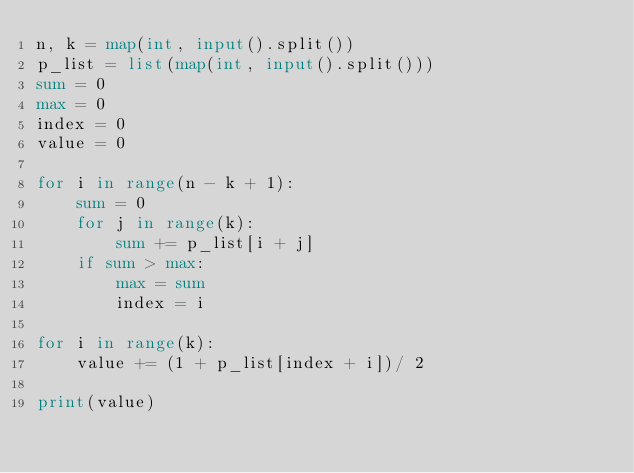Convert code to text. <code><loc_0><loc_0><loc_500><loc_500><_Python_>n, k = map(int, input().split())
p_list = list(map(int, input().split()))
sum = 0
max = 0
index = 0
value = 0

for i in range(n - k + 1):
    sum = 0
    for j in range(k):
        sum += p_list[i + j]
    if sum > max:
        max = sum
        index = i

for i in range(k):
    value += (1 + p_list[index + i])/ 2

print(value)
</code> 